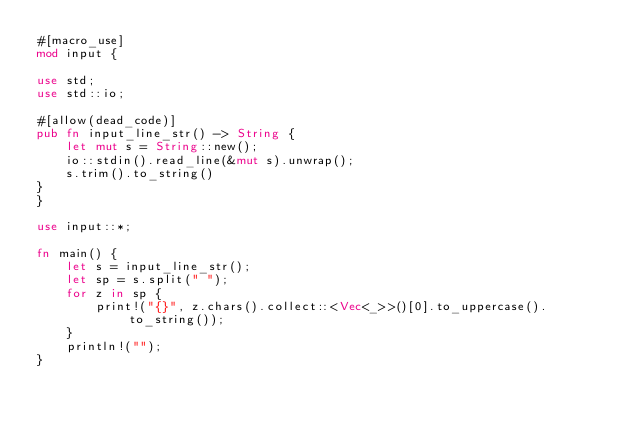Convert code to text. <code><loc_0><loc_0><loc_500><loc_500><_Rust_>#[macro_use]
mod input {

use std;
use std::io;

#[allow(dead_code)]
pub fn input_line_str() -> String {
    let mut s = String::new();
    io::stdin().read_line(&mut s).unwrap();
    s.trim().to_string()
}
}

use input::*;

fn main() {
    let s = input_line_str();
    let sp = s.split(" ");
    for z in sp {
        print!("{}", z.chars().collect::<Vec<_>>()[0].to_uppercase().to_string());
    }
    println!("");
}</code> 